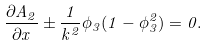Convert formula to latex. <formula><loc_0><loc_0><loc_500><loc_500>\frac { \partial A _ { 2 } } { \partial x } \pm \frac { 1 } { k ^ { 2 } } \phi _ { 3 } ( 1 - \phi _ { 3 } ^ { 2 } ) = 0 .</formula> 